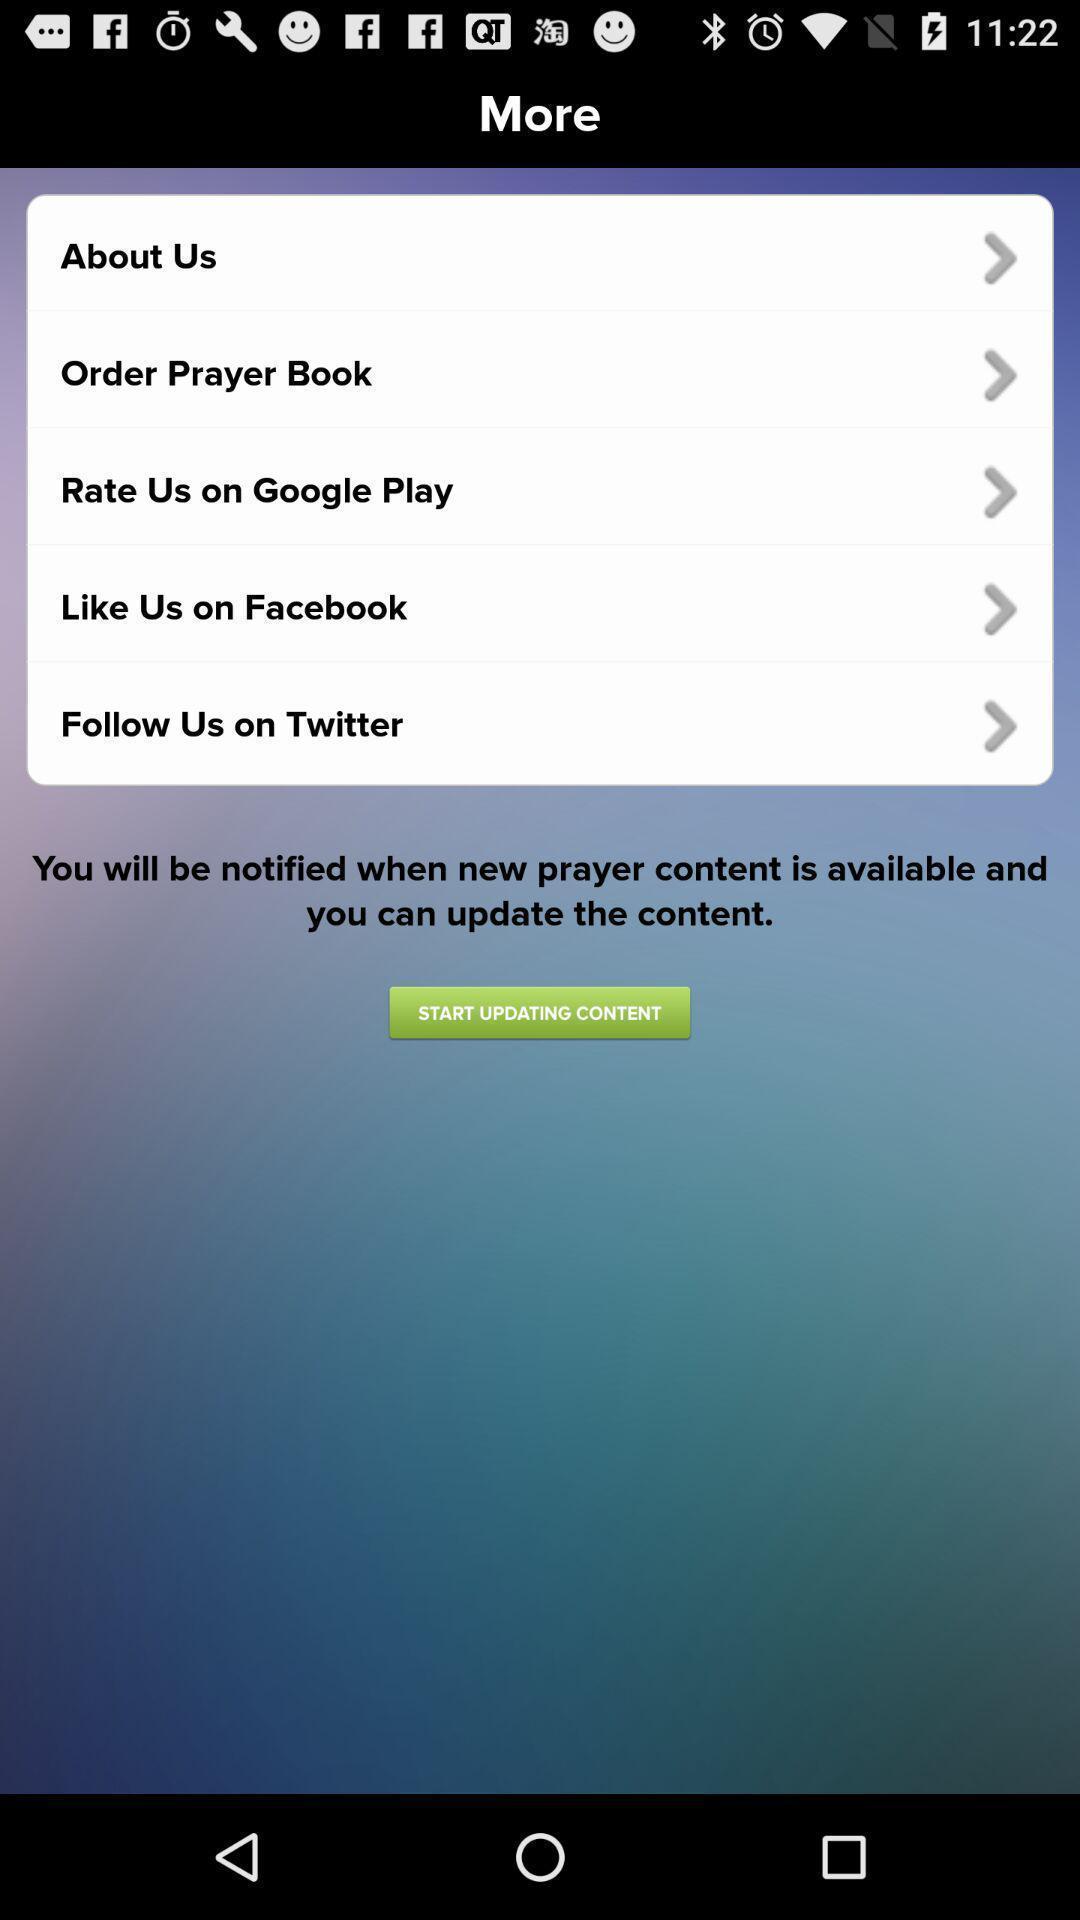Describe the key features of this screenshot. Screen shows more options page in the app. 